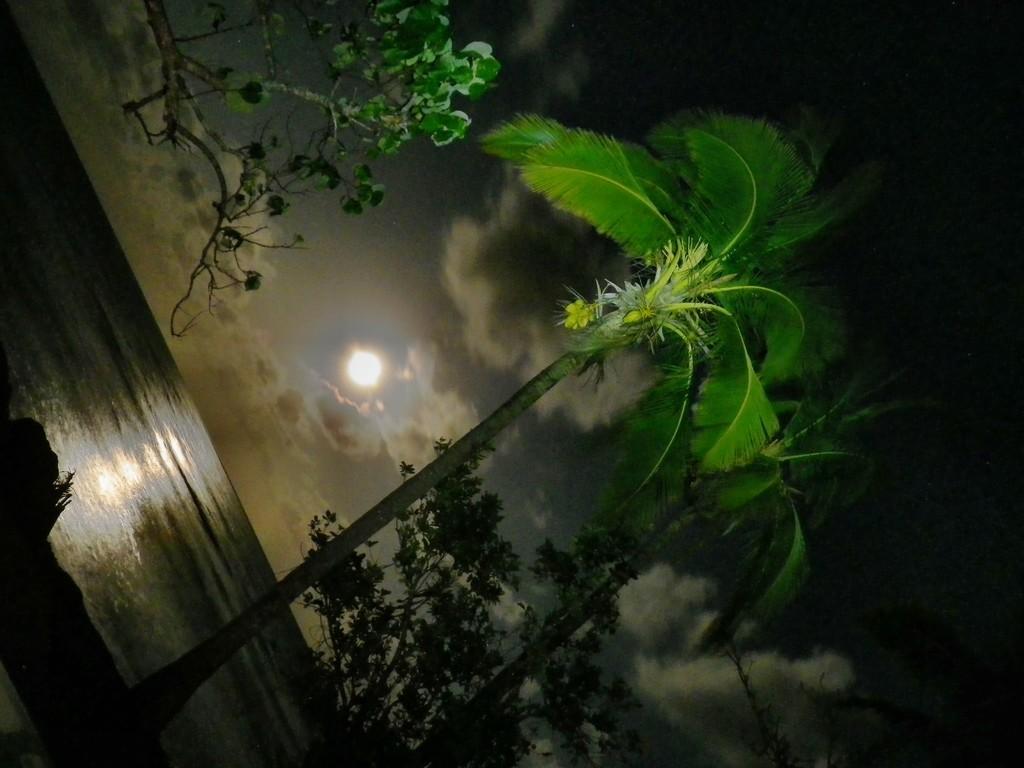Describe this image in one or two sentences. On the top left, there is a tree. At the bottom of the image, there are trees. In the background, there is a moon and there are clouds in the sky. 